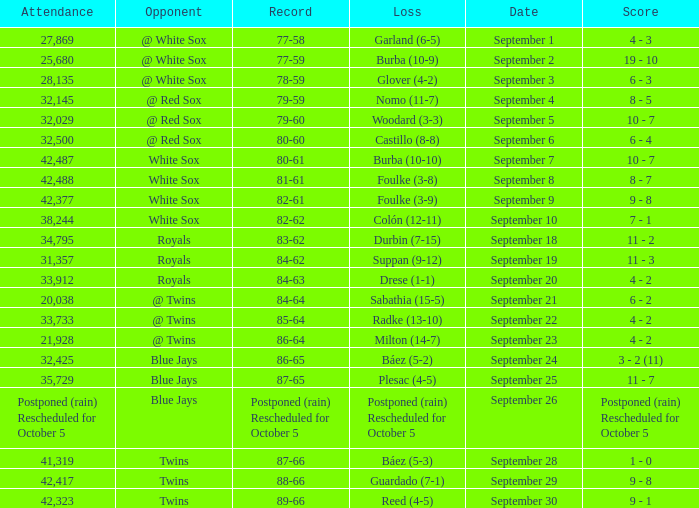What is the record of the game with 28,135 people in attendance? 78-59. 